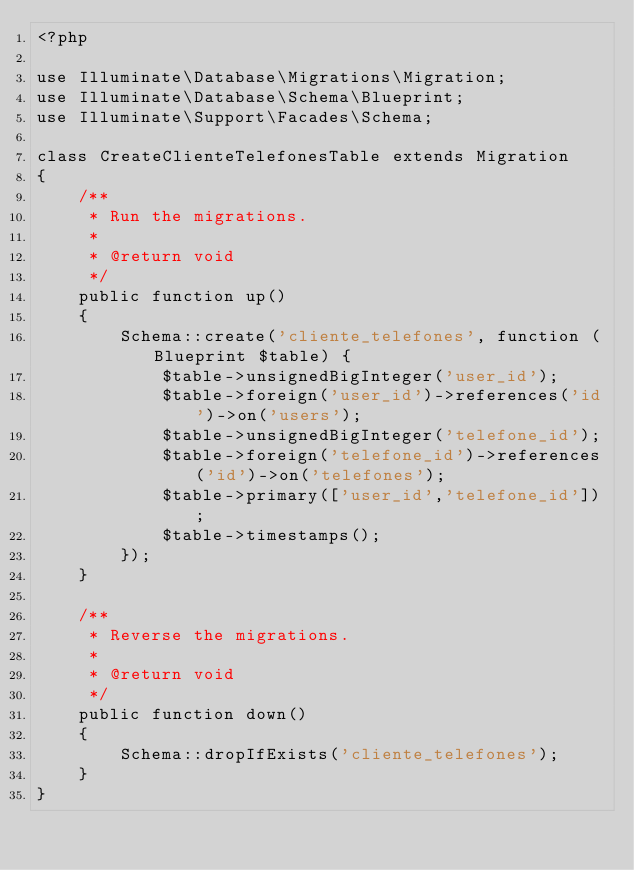Convert code to text. <code><loc_0><loc_0><loc_500><loc_500><_PHP_><?php

use Illuminate\Database\Migrations\Migration;
use Illuminate\Database\Schema\Blueprint;
use Illuminate\Support\Facades\Schema;

class CreateClienteTelefonesTable extends Migration
{
    /**
     * Run the migrations.
     *
     * @return void
     */
    public function up()
    {
        Schema::create('cliente_telefones', function (Blueprint $table) {
            $table->unsignedBigInteger('user_id');
            $table->foreign('user_id')->references('id')->on('users');
            $table->unsignedBigInteger('telefone_id');
            $table->foreign('telefone_id')->references('id')->on('telefones');
            $table->primary(['user_id','telefone_id']);
            $table->timestamps();
        });
    }

    /**
     * Reverse the migrations.
     *
     * @return void
     */
    public function down()
    {
        Schema::dropIfExists('cliente_telefones');
    }
}
</code> 